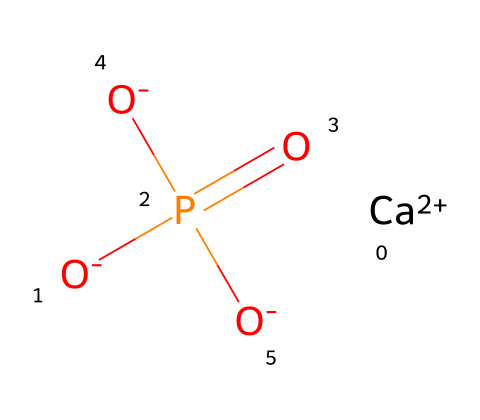What is the central atom in the phosphate structure? The phosphate structure shows phosphorus (P) as the central atom, signified by its arrangement bonded to four oxygen atoms.
Answer: phosphorus How many oxygen atoms are in this phosphate compound? By examining the structure, we can see that there are four oxygen (O) atoms attached to the phosphorus atom in the molecular representation.
Answer: four What is the charge of the calcium ion in this structure? The structure displays a calcium ion represented as [Ca+2], indicating it possesses a +2 charge due to the loss of two electrons.
Answer: +2 What type of bond connects phosphorus to oxygen? The connections between phosphorus and oxygen atoms include bonds with varying characteristics, but generally, they are covalent bonds as they share electrons.
Answer: covalent How does this structure relate to its role in baby formula? The phosphate group is essential for energy transfer and cellular function, key components in nutritional formulations, including baby formulas where it contributes to healthy development.
Answer: energy transfer What characteristic of this compound makes it suitable for nutrition? The presence of phosphate indicates that this compound can facilitate important biochemical processes like ATP synthesis, crucial for metabolic energy in nutritional settings.
Answer: ATP synthesis 